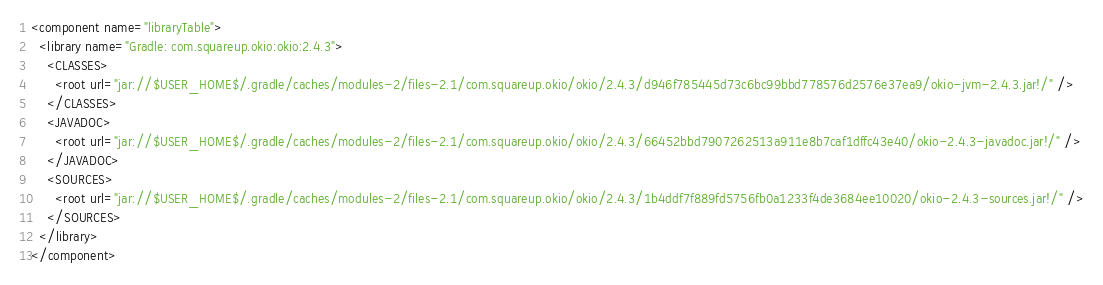<code> <loc_0><loc_0><loc_500><loc_500><_XML_><component name="libraryTable">
  <library name="Gradle: com.squareup.okio:okio:2.4.3">
    <CLASSES>
      <root url="jar://$USER_HOME$/.gradle/caches/modules-2/files-2.1/com.squareup.okio/okio/2.4.3/d946f785445d73c6bc99bbd778576d2576e37ea9/okio-jvm-2.4.3.jar!/" />
    </CLASSES>
    <JAVADOC>
      <root url="jar://$USER_HOME$/.gradle/caches/modules-2/files-2.1/com.squareup.okio/okio/2.4.3/66452bbd7907262513a911e8b7caf1dffc43e40/okio-2.4.3-javadoc.jar!/" />
    </JAVADOC>
    <SOURCES>
      <root url="jar://$USER_HOME$/.gradle/caches/modules-2/files-2.1/com.squareup.okio/okio/2.4.3/1b4ddf7f889fd5756fb0a1233f4de3684ee10020/okio-2.4.3-sources.jar!/" />
    </SOURCES>
  </library>
</component></code> 